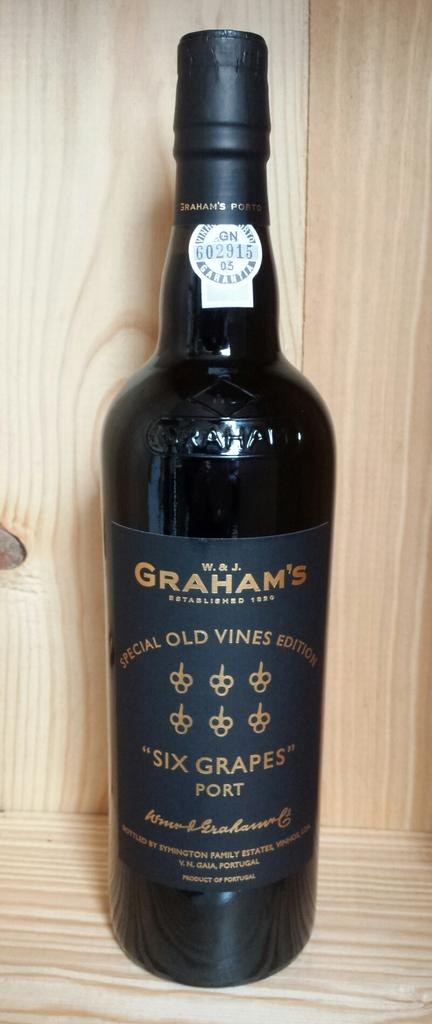<image>
Write a terse but informative summary of the picture. the word Graham's that is on a wine bottle 